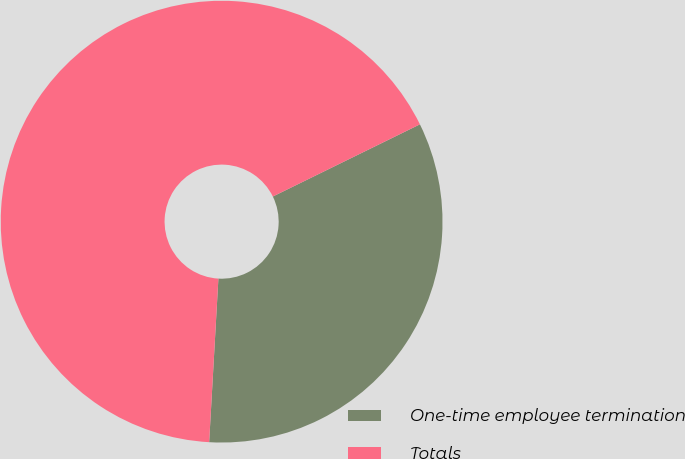<chart> <loc_0><loc_0><loc_500><loc_500><pie_chart><fcel>One-time employee termination<fcel>Totals<nl><fcel>33.16%<fcel>66.84%<nl></chart> 